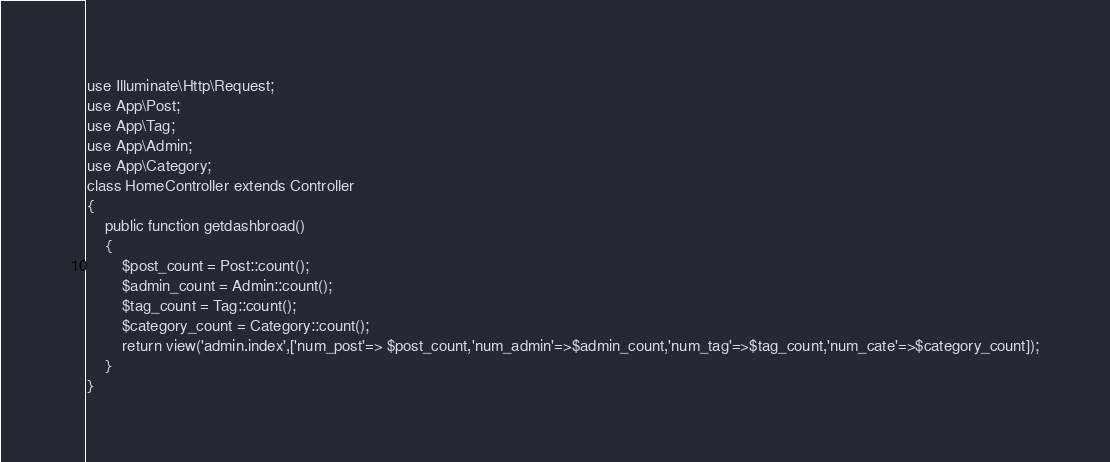Convert code to text. <code><loc_0><loc_0><loc_500><loc_500><_PHP_>
use Illuminate\Http\Request;
use App\Post;
use App\Tag;
use App\Admin;
use App\Category;
class HomeController extends Controller
{
    public function getdashbroad()	
    {
    	$post_count = Post::count();
    	$admin_count = Admin::count();
    	$tag_count = Tag::count();
    	$category_count = Category::count();
    	return view('admin.index',['num_post'=> $post_count,'num_admin'=>$admin_count,'num_tag'=>$tag_count,'num_cate'=>$category_count]);
    }
}
</code> 